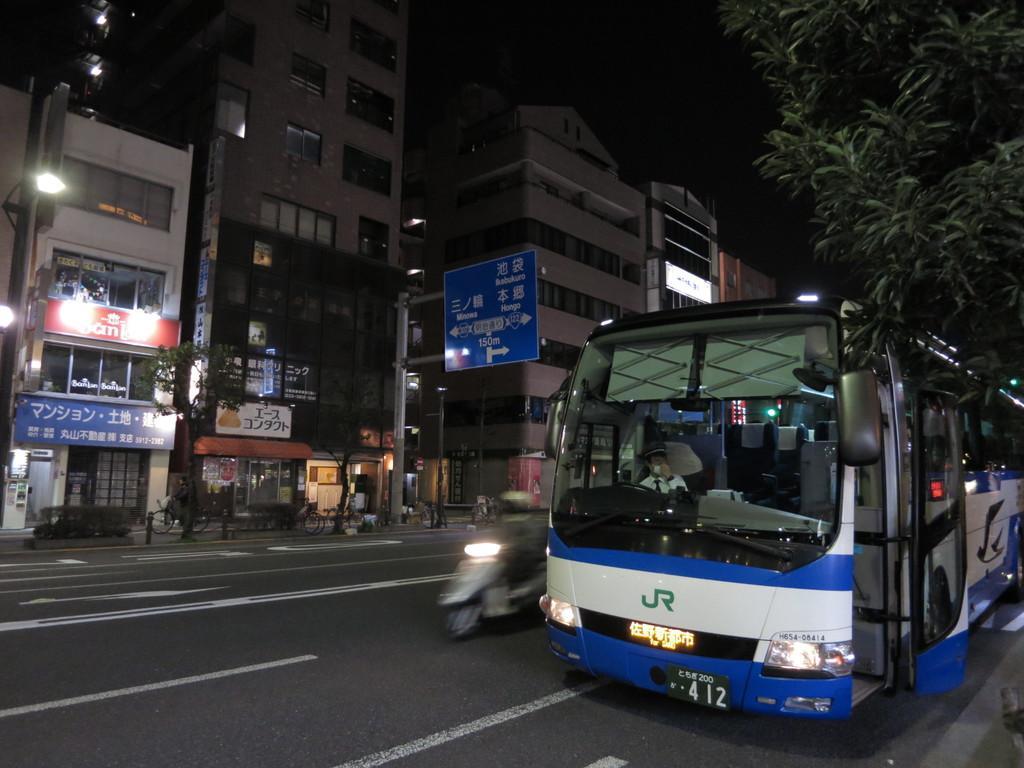Can you describe this image briefly? In this image, we can see vehicles on the road and in the background, there are buildings, trees, lights, boards, people and there are poles. 